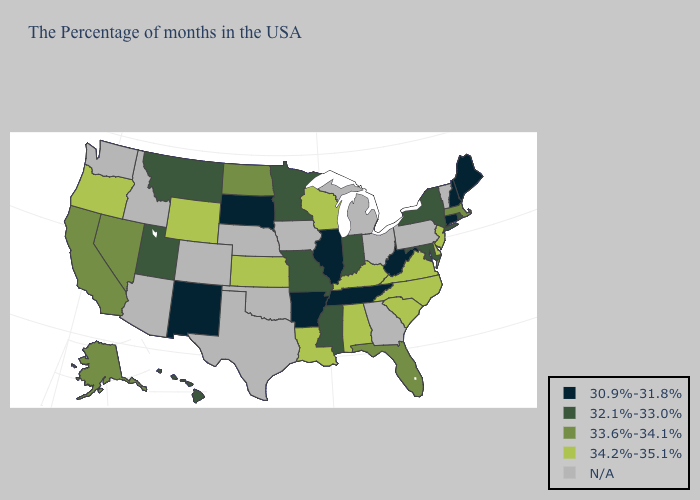How many symbols are there in the legend?
Be succinct. 5. Among the states that border Connecticut , which have the lowest value?
Concise answer only. Rhode Island, New York. Name the states that have a value in the range N/A?
Be succinct. Vermont, Pennsylvania, Ohio, Georgia, Michigan, Iowa, Nebraska, Oklahoma, Texas, Colorado, Arizona, Idaho, Washington. Does Mississippi have the lowest value in the USA?
Quick response, please. No. Does Wisconsin have the highest value in the MidWest?
Answer briefly. Yes. Among the states that border South Carolina , which have the highest value?
Concise answer only. North Carolina. What is the value of Oregon?
Write a very short answer. 34.2%-35.1%. What is the highest value in states that border Florida?
Write a very short answer. 34.2%-35.1%. Does the map have missing data?
Be succinct. Yes. Among the states that border Georgia , which have the highest value?
Give a very brief answer. North Carolina, South Carolina, Alabama. What is the value of Nevada?
Concise answer only. 33.6%-34.1%. What is the highest value in the West ?
Write a very short answer. 34.2%-35.1%. Is the legend a continuous bar?
Give a very brief answer. No. Which states have the lowest value in the MidWest?
Short answer required. Illinois, South Dakota. 